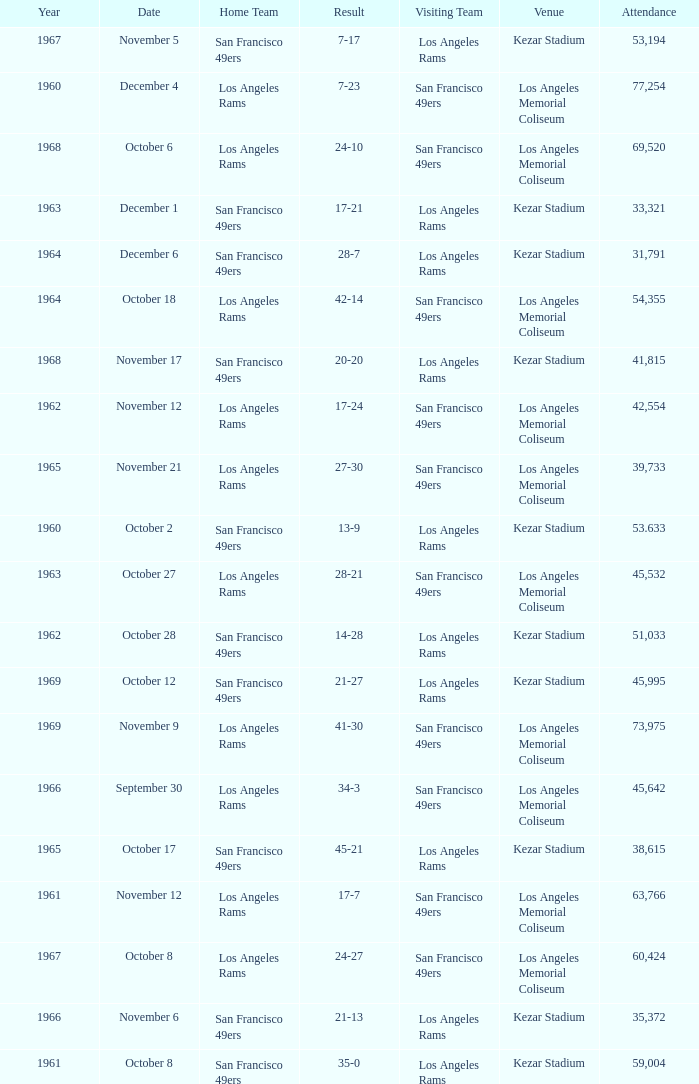Who is the home team when the san francisco 49ers are visiting with a result of 42-14? Los Angeles Rams. 